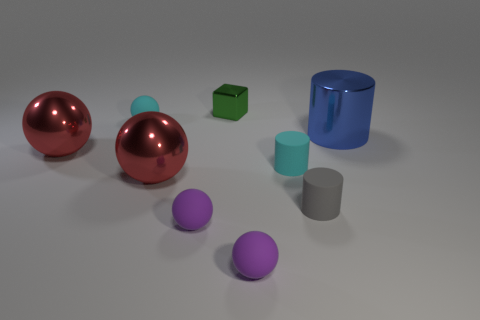There is a green metallic thing that is behind the rubber ball behind the gray rubber cylinder; what size is it?
Ensure brevity in your answer.  Small. Are there fewer tiny green cubes that are in front of the big blue cylinder than large cyan shiny objects?
Make the answer very short. No. The gray thing is what size?
Your answer should be very brief. Small. There is a small cyan thing to the left of the small matte sphere that is on the right side of the metallic block; is there a cube behind it?
Your answer should be compact. Yes. The gray matte object that is the same size as the cyan matte cylinder is what shape?
Make the answer very short. Cylinder. What number of big things are metal cylinders or red spheres?
Keep it short and to the point. 3. What is the color of the cylinder that is the same material as the green block?
Give a very brief answer. Blue. Do the cyan rubber object on the right side of the green shiny cube and the red object that is on the right side of the cyan matte sphere have the same shape?
Give a very brief answer. No. How many metal objects are gray cylinders or green objects?
Ensure brevity in your answer.  1. Is there anything else that is the same shape as the green metallic thing?
Give a very brief answer. No. 